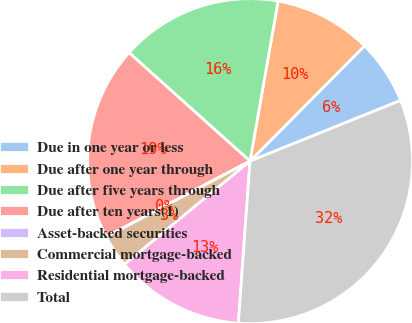Convert chart to OTSL. <chart><loc_0><loc_0><loc_500><loc_500><pie_chart><fcel>Due in one year or less<fcel>Due after one year through<fcel>Due after five years through<fcel>Due after ten years(1)<fcel>Asset-backed securities<fcel>Commercial mortgage-backed<fcel>Residential mortgage-backed<fcel>Total<nl><fcel>6.46%<fcel>9.68%<fcel>16.13%<fcel>19.35%<fcel>0.01%<fcel>3.23%<fcel>12.9%<fcel>32.24%<nl></chart> 